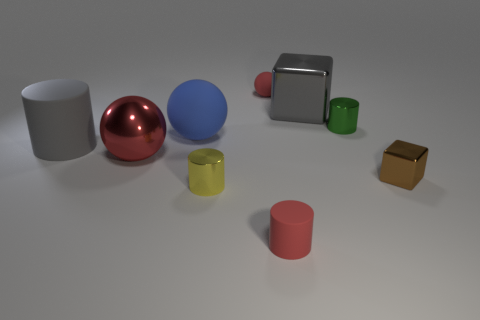Subtract 1 cylinders. How many cylinders are left? 3 Subtract all cylinders. How many objects are left? 5 Add 3 yellow cylinders. How many yellow cylinders exist? 4 Subtract 1 gray cylinders. How many objects are left? 8 Subtract all metal spheres. Subtract all tiny brown metal cubes. How many objects are left? 7 Add 9 big metallic spheres. How many big metallic spheres are left? 10 